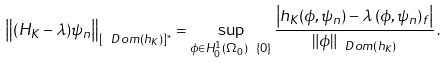Convert formula to latex. <formula><loc_0><loc_0><loc_500><loc_500>\left \| ( H _ { K } - \lambda ) \psi _ { n } \right \| _ { [ \ D o m ( h _ { K } ) ] ^ { * } } = \sup _ { \phi \in H _ { 0 } ^ { 1 } ( \Omega _ { 0 } ) \ \{ 0 \} } \frac { \left | h _ { K } ( \phi , \psi _ { n } ) - \lambda \, ( \phi , \psi _ { n } ) _ { f } \right | } { \| \phi \| _ { \ D o m ( h _ { K } ) } } \, .</formula> 